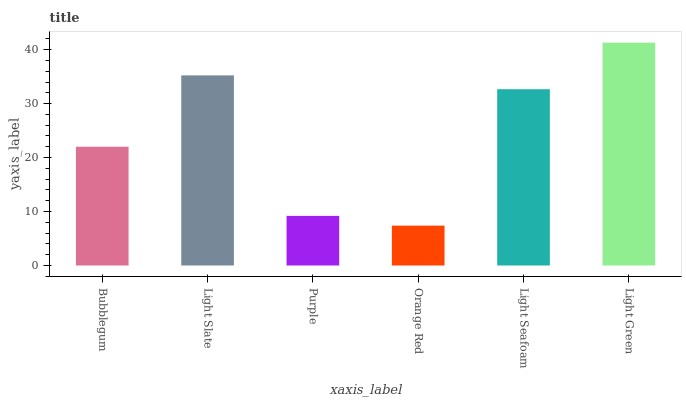Is Orange Red the minimum?
Answer yes or no. Yes. Is Light Green the maximum?
Answer yes or no. Yes. Is Light Slate the minimum?
Answer yes or no. No. Is Light Slate the maximum?
Answer yes or no. No. Is Light Slate greater than Bubblegum?
Answer yes or no. Yes. Is Bubblegum less than Light Slate?
Answer yes or no. Yes. Is Bubblegum greater than Light Slate?
Answer yes or no. No. Is Light Slate less than Bubblegum?
Answer yes or no. No. Is Light Seafoam the high median?
Answer yes or no. Yes. Is Bubblegum the low median?
Answer yes or no. Yes. Is Light Slate the high median?
Answer yes or no. No. Is Light Seafoam the low median?
Answer yes or no. No. 